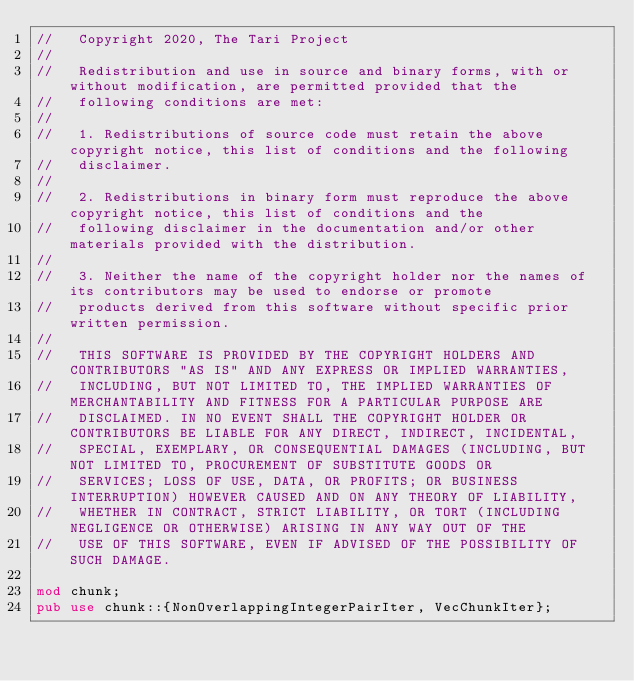Convert code to text. <code><loc_0><loc_0><loc_500><loc_500><_Rust_>//   Copyright 2020, The Tari Project
//
//   Redistribution and use in source and binary forms, with or without modification, are permitted provided that the
//   following conditions are met:
//
//   1. Redistributions of source code must retain the above copyright notice, this list of conditions and the following
//   disclaimer.
//
//   2. Redistributions in binary form must reproduce the above copyright notice, this list of conditions and the
//   following disclaimer in the documentation and/or other materials provided with the distribution.
//
//   3. Neither the name of the copyright holder nor the names of its contributors may be used to endorse or promote
//   products derived from this software without specific prior written permission.
//
//   THIS SOFTWARE IS PROVIDED BY THE COPYRIGHT HOLDERS AND CONTRIBUTORS "AS IS" AND ANY EXPRESS OR IMPLIED WARRANTIES,
//   INCLUDING, BUT NOT LIMITED TO, THE IMPLIED WARRANTIES OF MERCHANTABILITY AND FITNESS FOR A PARTICULAR PURPOSE ARE
//   DISCLAIMED. IN NO EVENT SHALL THE COPYRIGHT HOLDER OR CONTRIBUTORS BE LIABLE FOR ANY DIRECT, INDIRECT, INCIDENTAL,
//   SPECIAL, EXEMPLARY, OR CONSEQUENTIAL DAMAGES (INCLUDING, BUT NOT LIMITED TO, PROCUREMENT OF SUBSTITUTE GOODS OR
//   SERVICES; LOSS OF USE, DATA, OR PROFITS; OR BUSINESS INTERRUPTION) HOWEVER CAUSED AND ON ANY THEORY OF LIABILITY,
//   WHETHER IN CONTRACT, STRICT LIABILITY, OR TORT (INCLUDING NEGLIGENCE OR OTHERWISE) ARISING IN ANY WAY OUT OF THE
//   USE OF THIS SOFTWARE, EVEN IF ADVISED OF THE POSSIBILITY OF SUCH DAMAGE.

mod chunk;
pub use chunk::{NonOverlappingIntegerPairIter, VecChunkIter};
</code> 